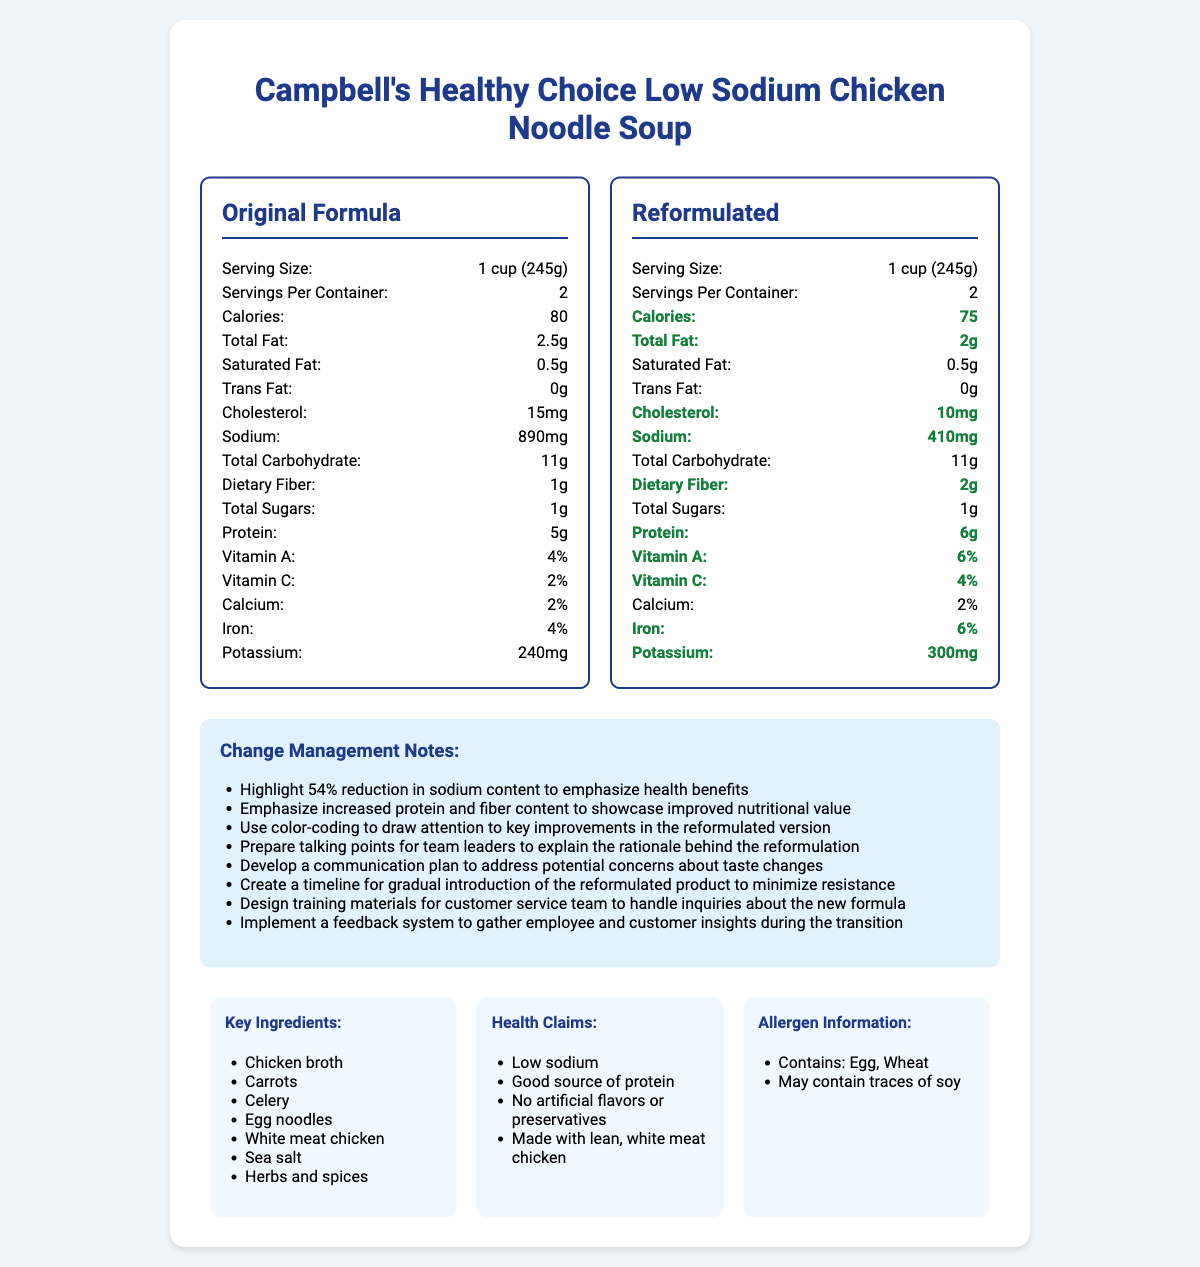what is the serving size for both the original and reformulated soups? The serving size is listed as "1 cup (245g)" for both the original and reformulated versions of the soup.
Answer: 1 cup (245g) how many calories are in the reformulated soup? The reformulated soup contains 75 calories, as indicated in its nutritional label.
Answer: 75 what is the reduction in sodium content between the original and reformulated soups? The original soup contains 890mg of sodium, while the reformulated version contains 410mg. The reduction is 890mg - 410mg = 480mg.
Answer: 480mg what improvements can be seen in the reformulated soup? The reformulated soup has improvements in reduced calories, fat, cholesterol, and sodium, and increased dietary fiber, protein, vitamins A and C, iron, and potassium.
Answer: Reduced calories, fat, cholesterol, sodium, increased dietary fiber, protein, vitamins A and C, iron, and potassium which ingredient might cause an allergic reaction in some people? A. Chicken broth B. Carrots C. Egg noodles D. Sea salt The allergen information lists "Contains: Egg, Wheat," indicating that egg noodles might cause an allergic reaction.
Answer: C. Egg noodles is the original soup higher in calories than the reformulated soup? The original soup has 80 calories, while the reformulated version has 75 calories, making the original higher in calories.
Answer: Yes how has the dietary fiber content changed in the reformulated soup? The dietary fiber content in the reformulated soup has increased from 1g to 2g, as indicated in the nutrient comparison.
Answer: Increased from 1g to 2g identify a health claim associated with the reformulated soup. A. High sodium B. Low trans fat C. Good source of protein D. Contains artificial flavors The health claims include "Low sodium," "Good source of protein," "No artificial flavors or preservatives," and "Made with lean, white meat chicken." Option C is the correct health claim.
Answer: C. Good source of protein has the cholesterol content improved in the reformulated soup? The cholesterol content in the reformulated soup has improved, reducing from 15mg to 10mg.
Answer: Yes summarize the main idea of the document. The document provides a detailed comparison of the nutritional information between the original and reformulated versions of the soup, emphasizing the health benefits and changes made in the new formula. It includes additional sections for change management, key ingredients, health claims, and allergen information.
Answer: The document compares the nutritional facts of the original and reformulated low-sodium chicken noodle soup, highlighting key improvements in the reformulated version, such as reduced sodium, calories, fat, and cholesterol, and increased fiber, protein, and vitamins. It also includes change management notes, key ingredients, health claims, and allergen information. how many servings are in each container? The document lists "Servings Per Container: 2" for both the original and reformulated versions.
Answer: 2 are there any changes to the total sugar content in the reformulated soup? The total sugars remain the same at 1g in both the original and reformulated soups.
Answer: No what is the rationale behind the product reformulation? The document provides the nutritional improvements and change management notes but does not detail the specific rationale behind the product reformulation.
Answer: Not enough information 